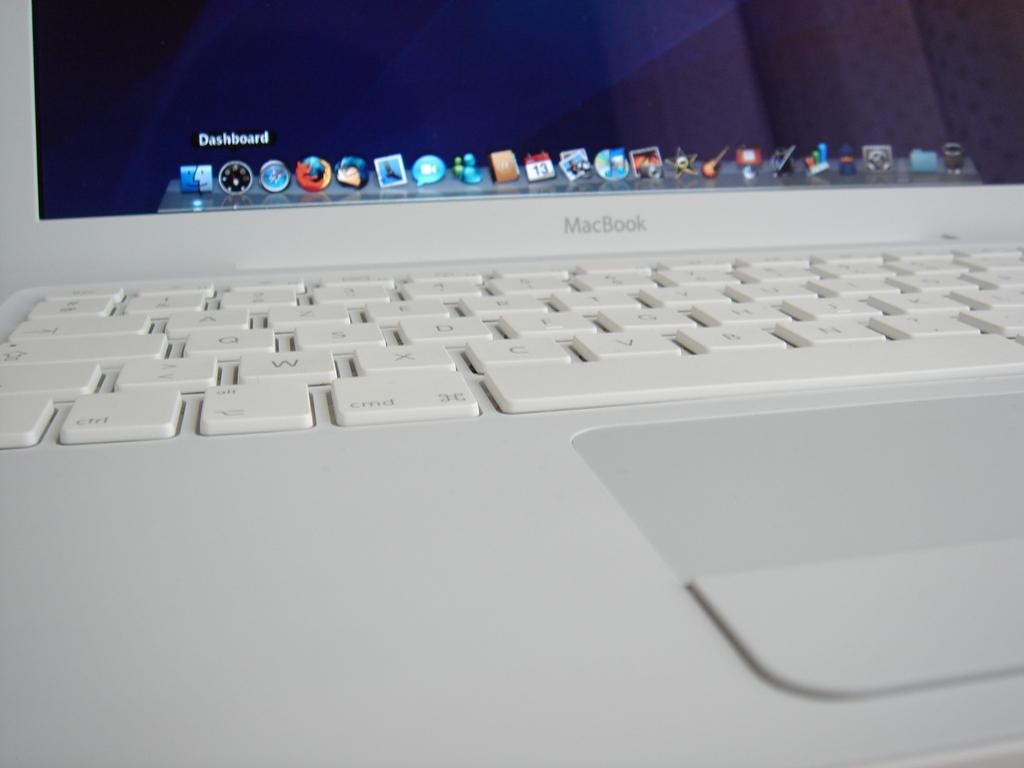Provide a one-sentence caption for the provided image. A keyboard and the bottom part of the screen for a white macbook. 